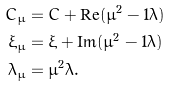Convert formula to latex. <formula><loc_0><loc_0><loc_500><loc_500>C _ { \mu } & = C + \text {Re} ( \mu ^ { 2 } - 1 \bar { \lambda } ) \\ \xi _ { \mu } & = \xi + \text {Im} ( \mu ^ { 2 } - 1 \bar { \lambda } ) \\ \lambda _ { \mu } & = \bar { \mu } ^ { 2 } \lambda .</formula> 